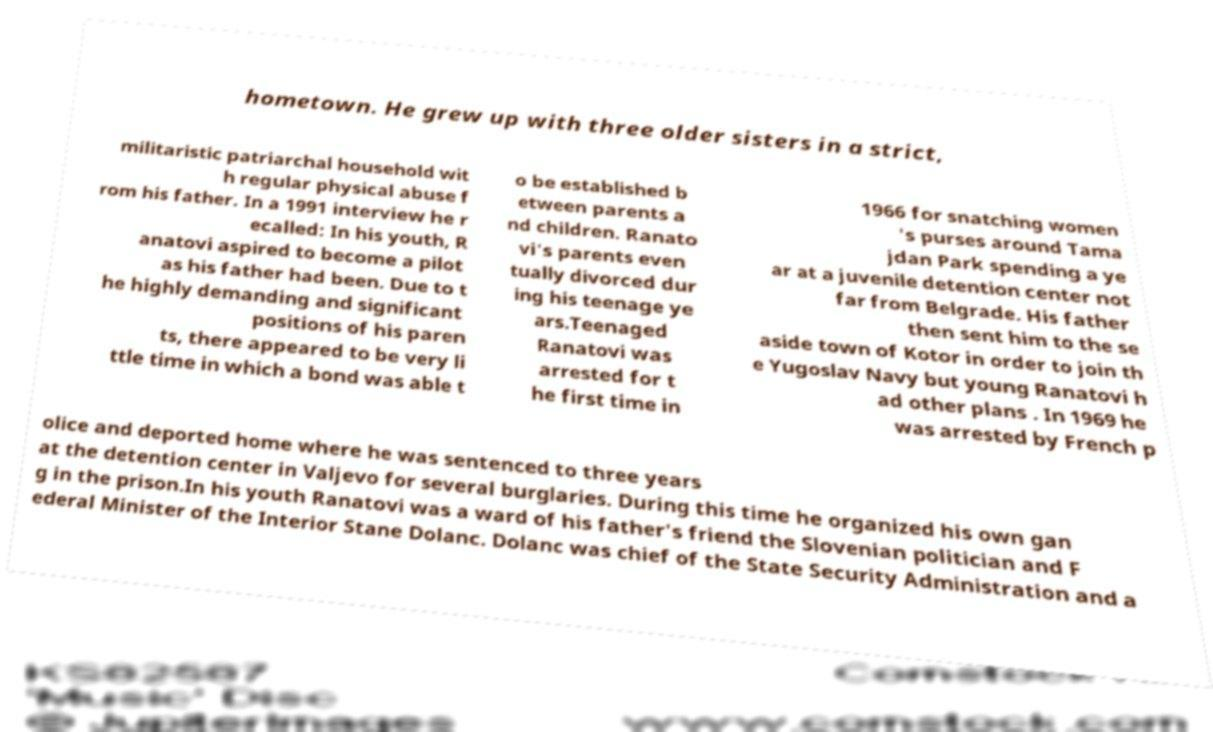Please identify and transcribe the text found in this image. hometown. He grew up with three older sisters in a strict, militaristic patriarchal household wit h regular physical abuse f rom his father. In a 1991 interview he r ecalled: In his youth, R anatovi aspired to become a pilot as his father had been. Due to t he highly demanding and significant positions of his paren ts, there appeared to be very li ttle time in which a bond was able t o be established b etween parents a nd children. Ranato vi's parents even tually divorced dur ing his teenage ye ars.Teenaged Ranatovi was arrested for t he first time in 1966 for snatching women 's purses around Tama jdan Park spending a ye ar at a juvenile detention center not far from Belgrade. His father then sent him to the se aside town of Kotor in order to join th e Yugoslav Navy but young Ranatovi h ad other plans . In 1969 he was arrested by French p olice and deported home where he was sentenced to three years at the detention center in Valjevo for several burglaries. During this time he organized his own gan g in the prison.In his youth Ranatovi was a ward of his father's friend the Slovenian politician and F ederal Minister of the Interior Stane Dolanc. Dolanc was chief of the State Security Administration and a 